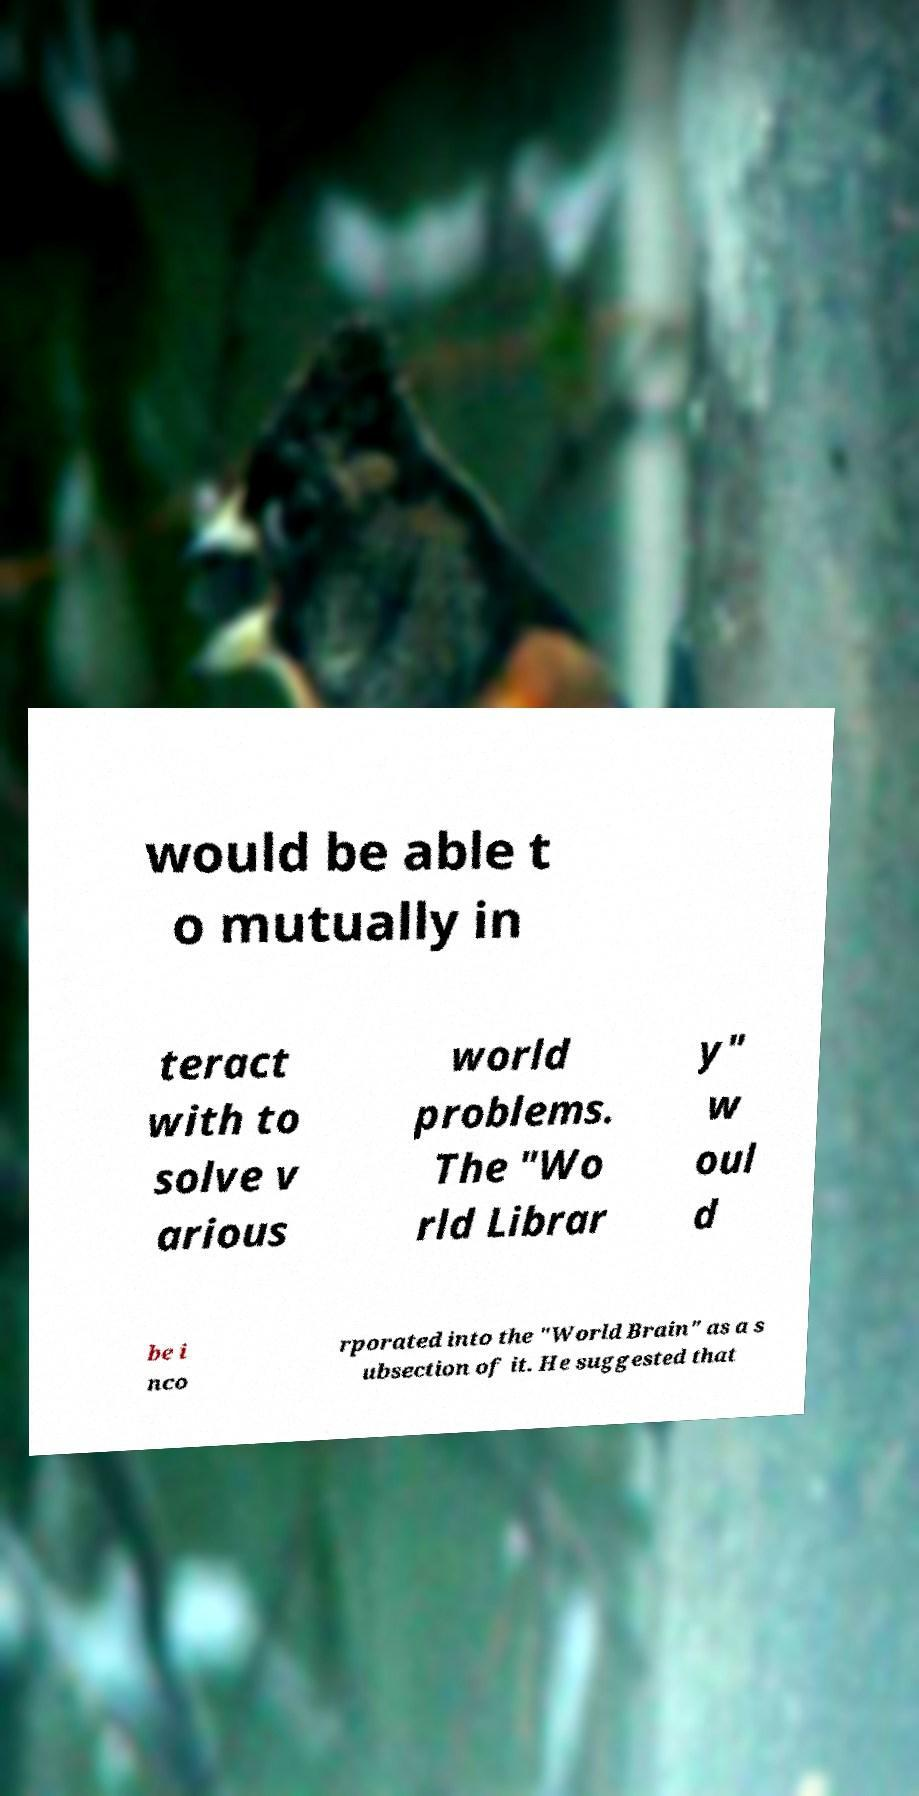Can you read and provide the text displayed in the image?This photo seems to have some interesting text. Can you extract and type it out for me? would be able t o mutually in teract with to solve v arious world problems. The "Wo rld Librar y" w oul d be i nco rporated into the "World Brain" as a s ubsection of it. He suggested that 